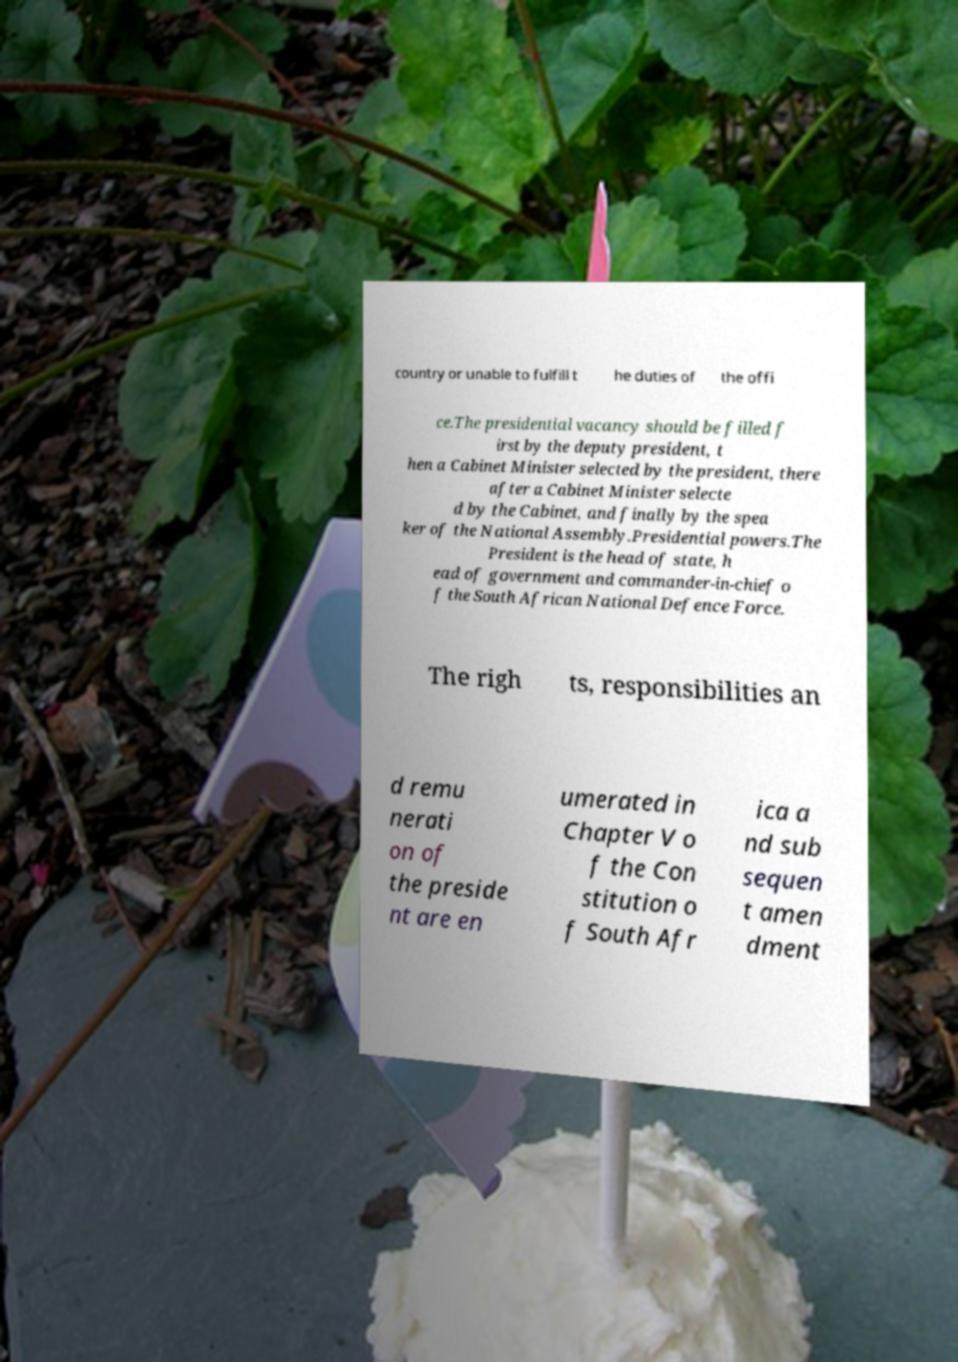I need the written content from this picture converted into text. Can you do that? country or unable to fulfill t he duties of the offi ce.The presidential vacancy should be filled f irst by the deputy president, t hen a Cabinet Minister selected by the president, there after a Cabinet Minister selecte d by the Cabinet, and finally by the spea ker of the National Assembly.Presidential powers.The President is the head of state, h ead of government and commander-in-chief o f the South African National Defence Force. The righ ts, responsibilities an d remu nerati on of the preside nt are en umerated in Chapter V o f the Con stitution o f South Afr ica a nd sub sequen t amen dment 